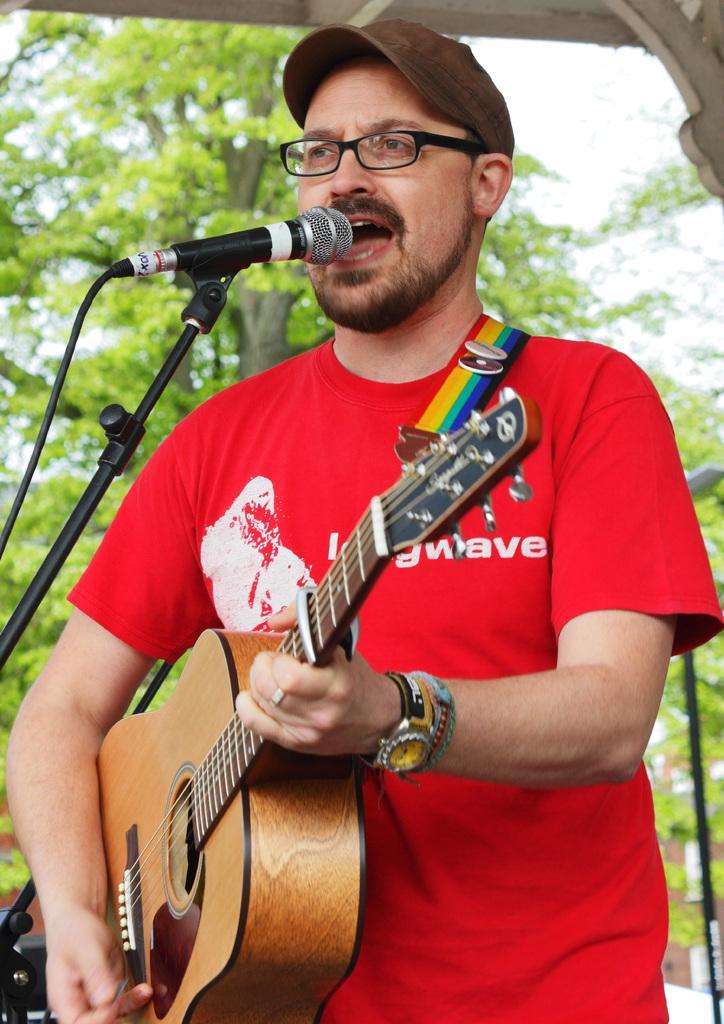Please provide a concise description of this image. In the image we can see one person he is singing we can see his mouth is open. And he is playing guitar in front of him there is a microphone. Coming to the background there is a tree. 